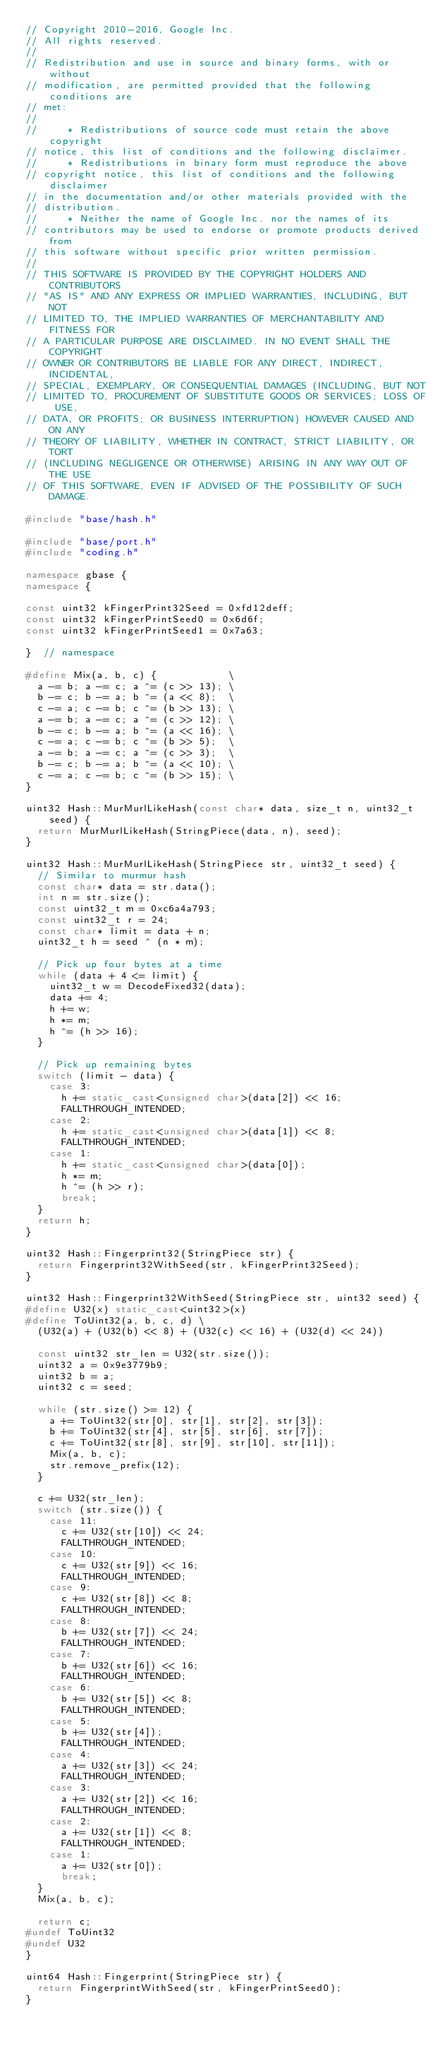Convert code to text. <code><loc_0><loc_0><loc_500><loc_500><_C++_>// Copyright 2010-2016, Google Inc.
// All rights reserved.
//
// Redistribution and use in source and binary forms, with or without
// modification, are permitted provided that the following conditions are
// met:
//
//     * Redistributions of source code must retain the above copyright
// notice, this list of conditions and the following disclaimer.
//     * Redistributions in binary form must reproduce the above
// copyright notice, this list of conditions and the following disclaimer
// in the documentation and/or other materials provided with the
// distribution.
//     * Neither the name of Google Inc. nor the names of its
// contributors may be used to endorse or promote products derived from
// this software without specific prior written permission.
//
// THIS SOFTWARE IS PROVIDED BY THE COPYRIGHT HOLDERS AND CONTRIBUTORS
// "AS IS" AND ANY EXPRESS OR IMPLIED WARRANTIES, INCLUDING, BUT NOT
// LIMITED TO, THE IMPLIED WARRANTIES OF MERCHANTABILITY AND FITNESS FOR
// A PARTICULAR PURPOSE ARE DISCLAIMED. IN NO EVENT SHALL THE COPYRIGHT
// OWNER OR CONTRIBUTORS BE LIABLE FOR ANY DIRECT, INDIRECT, INCIDENTAL,
// SPECIAL, EXEMPLARY, OR CONSEQUENTIAL DAMAGES (INCLUDING, BUT NOT
// LIMITED TO, PROCUREMENT OF SUBSTITUTE GOODS OR SERVICES; LOSS OF USE,
// DATA, OR PROFITS; OR BUSINESS INTERRUPTION) HOWEVER CAUSED AND ON ANY
// THEORY OF LIABILITY, WHETHER IN CONTRACT, STRICT LIABILITY, OR TORT
// (INCLUDING NEGLIGENCE OR OTHERWISE) ARISING IN ANY WAY OUT OF THE USE
// OF THIS SOFTWARE, EVEN IF ADVISED OF THE POSSIBILITY OF SUCH DAMAGE.

#include "base/hash.h"

#include "base/port.h"
#include "coding.h"

namespace gbase {
namespace {

const uint32 kFingerPrint32Seed = 0xfd12deff;
const uint32 kFingerPrintSeed0 = 0x6d6f;
const uint32 kFingerPrintSeed1 = 0x7a63;

}  // namespace

#define Mix(a, b, c) {            \
  a -= b; a -= c; a ^= (c >> 13); \
  b -= c; b -= a; b ^= (a << 8);  \
  c -= a; c -= b; c ^= (b >> 13); \
  a -= b; a -= c; a ^= (c >> 12); \
  b -= c; b -= a; b ^= (a << 16); \
  c -= a; c -= b; c ^= (b >> 5);  \
  a -= b; a -= c; a ^= (c >> 3);  \
  b -= c; b -= a; b ^= (a << 10); \
  c -= a; c -= b; c ^= (b >> 15); \
}

uint32 Hash::MurMurlLikeHash(const char* data, size_t n, uint32_t seed) {
  return MurMurlLikeHash(StringPiece(data, n), seed);
}

uint32 Hash::MurMurlLikeHash(StringPiece str, uint32_t seed) {
  // Similar to murmur hash
  const char* data = str.data();
  int n = str.size();
  const uint32_t m = 0xc6a4a793;
  const uint32_t r = 24;
  const char* limit = data + n;
  uint32_t h = seed ^ (n * m);

  // Pick up four bytes at a time
  while (data + 4 <= limit) {
    uint32_t w = DecodeFixed32(data);
    data += 4;
    h += w;
    h *= m;
    h ^= (h >> 16);
  }

  // Pick up remaining bytes
  switch (limit - data) {
    case 3:
      h += static_cast<unsigned char>(data[2]) << 16;
      FALLTHROUGH_INTENDED;
    case 2:
      h += static_cast<unsigned char>(data[1]) << 8;
      FALLTHROUGH_INTENDED;
    case 1:
      h += static_cast<unsigned char>(data[0]);
      h *= m;
      h ^= (h >> r);
      break;
  }
  return h;
}

uint32 Hash::Fingerprint32(StringPiece str) {
  return Fingerprint32WithSeed(str, kFingerPrint32Seed);
}

uint32 Hash::Fingerprint32WithSeed(StringPiece str, uint32 seed) {
#define U32(x) static_cast<uint32>(x)
#define ToUint32(a, b, c, d) \
  (U32(a) + (U32(b) << 8) + (U32(c) << 16) + (U32(d) << 24))

  const uint32 str_len = U32(str.size());
  uint32 a = 0x9e3779b9;
  uint32 b = a;
  uint32 c = seed;

  while (str.size() >= 12) {
    a += ToUint32(str[0], str[1], str[2], str[3]);
    b += ToUint32(str[4], str[5], str[6], str[7]);
    c += ToUint32(str[8], str[9], str[10], str[11]);
    Mix(a, b, c);
    str.remove_prefix(12);
  }

  c += U32(str_len);
  switch (str.size()) {
    case 11:
      c += U32(str[10]) << 24;
      FALLTHROUGH_INTENDED;
    case 10:
      c += U32(str[9]) << 16;
      FALLTHROUGH_INTENDED;
    case 9:
      c += U32(str[8]) << 8;
      FALLTHROUGH_INTENDED;
    case 8:
      b += U32(str[7]) << 24;
      FALLTHROUGH_INTENDED;
    case 7:
      b += U32(str[6]) << 16;
      FALLTHROUGH_INTENDED;
    case 6:
      b += U32(str[5]) << 8;
      FALLTHROUGH_INTENDED;
    case 5:
      b += U32(str[4]);
      FALLTHROUGH_INTENDED;
    case 4:
      a += U32(str[3]) << 24;
      FALLTHROUGH_INTENDED;
    case 3:
      a += U32(str[2]) << 16;
      FALLTHROUGH_INTENDED;
    case 2:
      a += U32(str[1]) << 8;
      FALLTHROUGH_INTENDED;
    case 1:
      a += U32(str[0]);
      break;
  }
  Mix(a, b, c);

  return c;
#undef ToUint32
#undef U32
}

uint64 Hash::Fingerprint(StringPiece str) {
  return FingerprintWithSeed(str, kFingerPrintSeed0);
}
</code> 